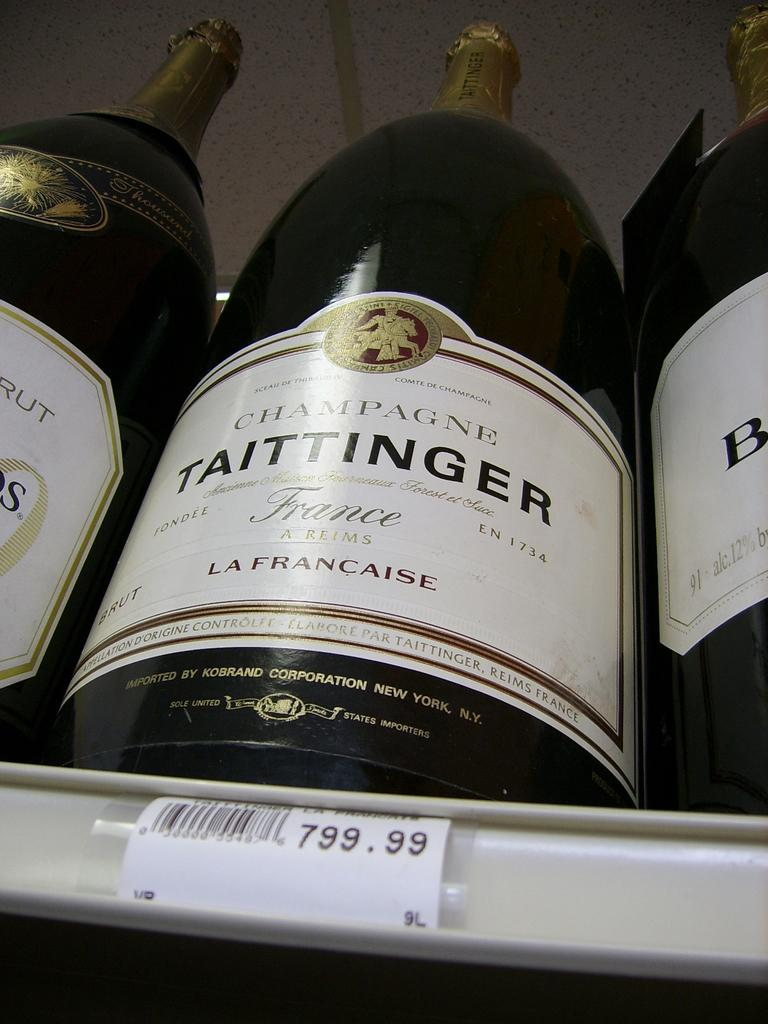<image>
Summarize the visual content of the image. taittinger wine is for sale for  799.99 